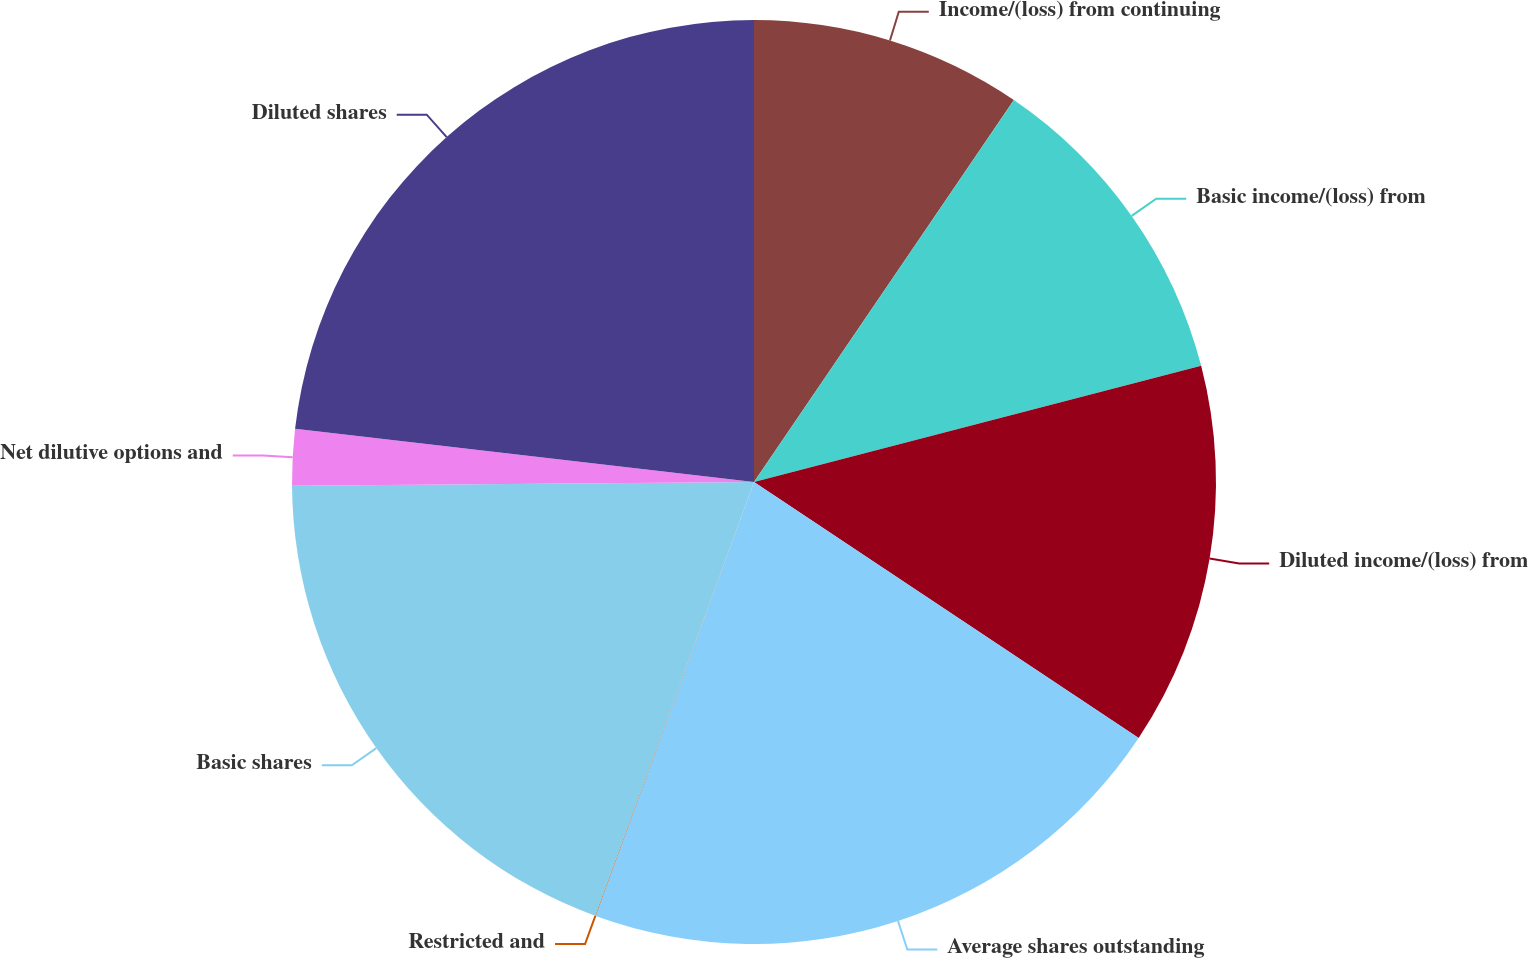<chart> <loc_0><loc_0><loc_500><loc_500><pie_chart><fcel>Income/(loss) from continuing<fcel>Basic income/(loss) from<fcel>Diluted income/(loss) from<fcel>Average shares outstanding<fcel>Restricted and<fcel>Basic shares<fcel>Net dilutive options and<fcel>Diluted shares<nl><fcel>9.51%<fcel>11.45%<fcel>13.39%<fcel>21.23%<fcel>0.02%<fcel>19.29%<fcel>1.96%<fcel>23.17%<nl></chart> 